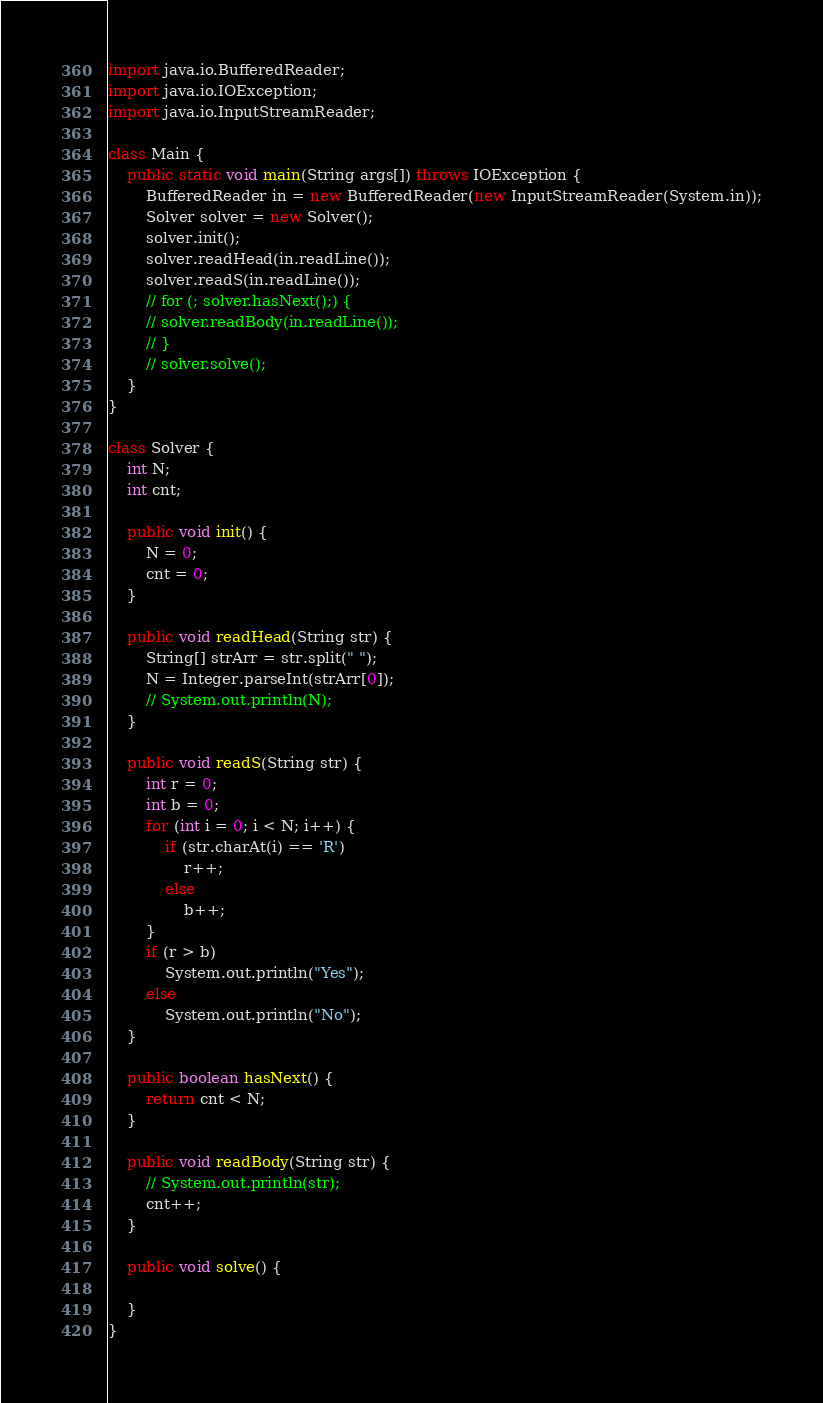<code> <loc_0><loc_0><loc_500><loc_500><_Java_>import java.io.BufferedReader;
import java.io.IOException;
import java.io.InputStreamReader;

class Main {
	public static void main(String args[]) throws IOException {
		BufferedReader in = new BufferedReader(new InputStreamReader(System.in));
		Solver solver = new Solver();
		solver.init();
		solver.readHead(in.readLine());
		solver.readS(in.readLine());
		// for (; solver.hasNext();) {
		// solver.readBody(in.readLine());
		// }
		// solver.solve();
	}
}

class Solver {
	int N;
	int cnt;

	public void init() {
		N = 0;
		cnt = 0;
	}

	public void readHead(String str) {
		String[] strArr = str.split(" ");
		N = Integer.parseInt(strArr[0]);
		// System.out.println(N);
	}

	public void readS(String str) {
		int r = 0;
		int b = 0;
		for (int i = 0; i < N; i++) {
			if (str.charAt(i) == 'R')
				r++;
			else
				b++;
		}
		if (r > b)
			System.out.println("Yes");
		else
			System.out.println("No");
	}

	public boolean hasNext() {
		return cnt < N;
	}

	public void readBody(String str) {
		// System.out.println(str);
		cnt++;
	}

	public void solve() {

	}
}
</code> 